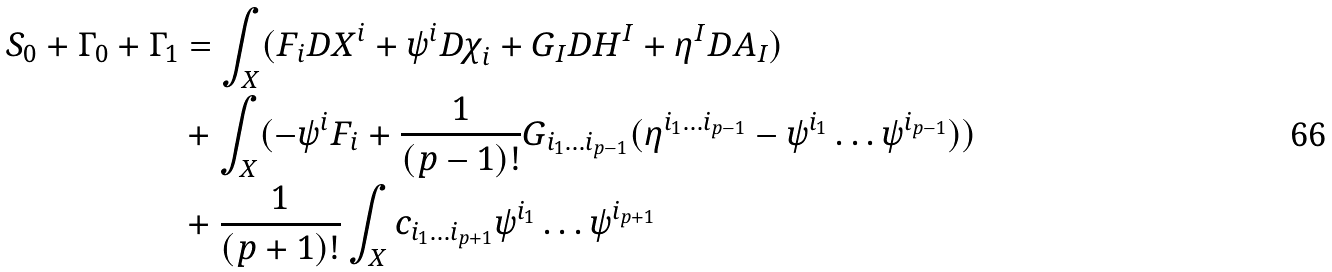Convert formula to latex. <formula><loc_0><loc_0><loc_500><loc_500>S _ { 0 } + \Gamma _ { 0 } + \Gamma _ { 1 } & = \int _ { X } ( { F } _ { i } { D X } ^ { i } + { \psi } ^ { i } { D \chi } _ { i } + G _ { I } D H ^ { I } + { \eta } ^ { I } { D A } _ { I } ) \\ & + \int _ { X } ( - \psi ^ { i } F _ { i } + \frac { 1 } { ( p - 1 ) ! } G _ { i _ { 1 } \dots i _ { p - 1 } } ( \eta ^ { i _ { 1 } \dots i _ { p - 1 } } - \psi ^ { i _ { 1 } } \dots \psi ^ { i _ { p - 1 } } ) ) \\ & + \frac { 1 } { ( p + 1 ) ! } \int _ { X } c _ { i _ { 1 } \dots i _ { p + 1 } } \psi ^ { i _ { 1 } } \dots \psi ^ { i _ { p + 1 } }</formula> 